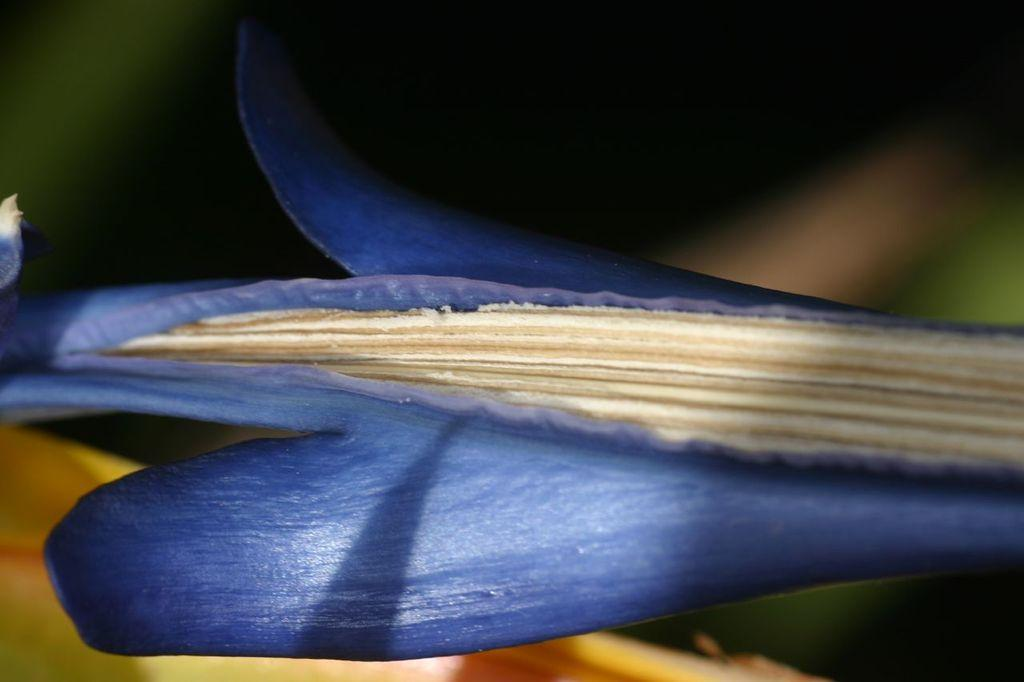What is the main subject of the image? There is a flower in the image. What type of cast can be seen on the back of the flower in the image? There is no cast present in the image, and the flower does not have a back. 